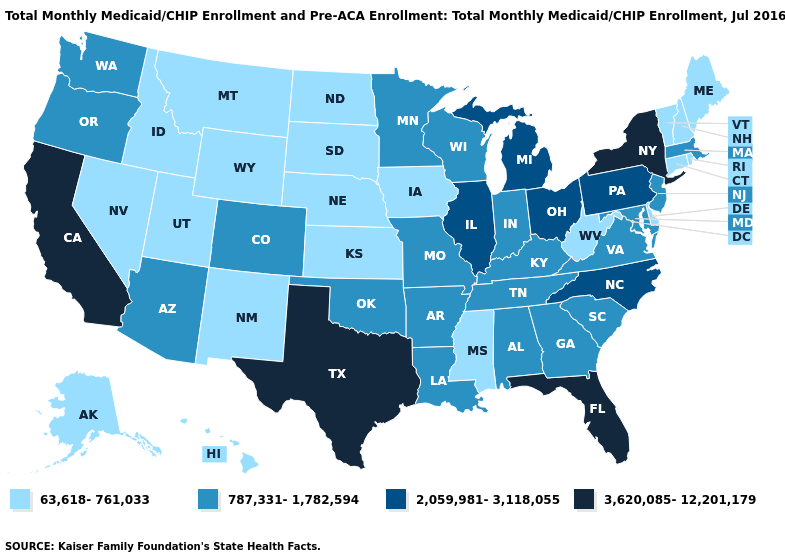Does Indiana have a lower value than New Hampshire?
Short answer required. No. Among the states that border New York , which have the lowest value?
Keep it brief. Connecticut, Vermont. Name the states that have a value in the range 3,620,085-12,201,179?
Short answer required. California, Florida, New York, Texas. Name the states that have a value in the range 2,059,981-3,118,055?
Quick response, please. Illinois, Michigan, North Carolina, Ohio, Pennsylvania. Which states have the lowest value in the USA?
Write a very short answer. Alaska, Connecticut, Delaware, Hawaii, Idaho, Iowa, Kansas, Maine, Mississippi, Montana, Nebraska, Nevada, New Hampshire, New Mexico, North Dakota, Rhode Island, South Dakota, Utah, Vermont, West Virginia, Wyoming. Does Indiana have the highest value in the MidWest?
Give a very brief answer. No. Does Tennessee have the lowest value in the South?
Quick response, please. No. Does Rhode Island have the same value as Minnesota?
Be succinct. No. Is the legend a continuous bar?
Answer briefly. No. Among the states that border Wyoming , does Utah have the highest value?
Concise answer only. No. Among the states that border New Jersey , does Delaware have the lowest value?
Keep it brief. Yes. What is the lowest value in the Northeast?
Short answer required. 63,618-761,033. Does Maryland have the highest value in the South?
Short answer required. No. How many symbols are there in the legend?
Keep it brief. 4. Does New York have the highest value in the USA?
Keep it brief. Yes. 